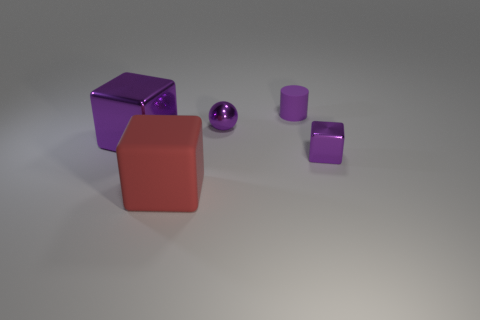Add 4 small shiny cubes. How many objects exist? 9 Subtract all cubes. How many objects are left? 2 Add 5 red blocks. How many red blocks are left? 6 Add 3 tiny objects. How many tiny objects exist? 6 Subtract 0 blue cubes. How many objects are left? 5 Subtract all big brown metallic things. Subtract all purple matte things. How many objects are left? 4 